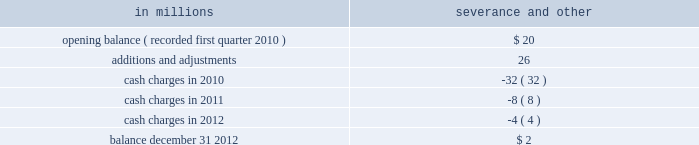The table presents a rollforward of the severance and other costs for approximately 1650 employees included in the 2010 restructuring charg- in millions severance and other .
As of december 31 , 2012 , 1638 employees had left the company under these programs .
Cellulosic bio-fuel tax credit in a memorandum dated june 28 , 2010 , the irs concluded that black liquor would qualify for the cellulosic bio-fuel tax credit of $ 1.01 per gallon pro- duced in 2009 .
On october 15 , 2010 , the irs ruled that companies may qualify in the same year for the $ 0.50 per gallon alternative fuel mixture credit and the $ 1.01 cellulosic bio-fuel tax credit for 2009 , but not for the same gallons of fuel produced and con- sumed .
To the extent a taxpayer changes its position and uses the $ 1.01 credit , it must re-pay the refunds they received as alternative fuel mixture credits attributable to the gallons converted to the cellulosic bio-fuel credit .
The repayment of this refund must include interest .
One important difference between the two credits is that the $ 1.01 credit must be credited against a company 2019s federal tax liability , and the credit may be carried forward through 2015 .
In contrast , the $ 0.50 credit is refundable in cash .
Also , the cellulosic bio- fuel credit is required to be included in federal tax- able income .
The company filed an application with the irs on november 18 , 2010 , to receive the required registra- tion code to become a registered cellulosic bio-fuel producer .
The company received its registration code on february 28 , 2011 .
The company has evaluated the optimal use of the two credits with respect to gallons produced in 2009 .
Considerations include uncertainty around future federal taxable income , the taxability of the alter- native fuel mixture credit , future liquidity and uses of cash such as , but not limited to , acquisitions , debt repayments and voluntary pension contributions versus repayment of alternative fuel mixture credits with interest .
At the present time , the company does not intend to convert any gallons under the alter- native fuel mixture credit to gallons under the cellulosic bio-fuel credit .
On july 19 , 2011 the com- pany filed an amended 2009 tax return claiming alternative fuel mixture tax credits as non-taxable income .
If that amended position is not upheld , the company will re-evaluate its position with regard to alternative fuel mixture gallons produced in 2009 .
During 2009 , the company produced 64 million gal- lons of black liquor that were not eligible for the alternative fuel mixture credit .
The company claimed these gallons for the cellulosic bio-fuel credit by amending the company 2019s 2009 tax return .
The impact of this amendment was included in the company 2019s 2010 fourth quarter income tax provision ( benefit ) , resulting in a $ 40 million net credit to tax expense .
Temple-inland , inc .
Also recognized an income tax benefit of $ 83 million in 2010 related to cellulosic bio-fuel credits .
As is the case with other tax credits , taxpayer claims are subject to possible future review by the irs which has the authority to propose adjustments to the amounts claimed , or credits received .
Note 5 acquisitions and joint ventures acquisitions 2013 : on january 3 , 2013 , international paper completed the acquisition ( effective date of acquis- ition on january 1 , 2013 ) of the shares of its joint venture partner , sabanci holding , in the turkish corrugated packaging company , olmuksa interna- tional paper sabanci ambalaj sanayi ve ticaret a.s .
( olmuksa ) , for a purchase price of $ 56 million .
The acquired shares represent 43.7% ( 43.7 % ) of olmuksa 2019s shares , and prior to this acquisition , international paper already held a 43.7% ( 43.7 % ) equity interest in olmuk- sa .
Thus , international paper now owns 87.4% ( 87.4 % ) of olmuksa 2019s outstanding and issued shares .
The company has not completed the valuation of assets acquired and liabilities assumed ; however , the company anticipates providing a preliminary pur- chase price allocation in its 2013 first quarter form 10-q filing .
Because the transaction resulted in international paper becoming the majority shareholder , owning 87.4% ( 87.4 % ) of olmuksa 2019s shares , its completion triggered a mandatory call for tender of the remaining public shares .
Also as a result of international paper taking majority control of the entity , olmuksa 2019s financial results will be consolidated with our industrial pack- aging segment beginning with the effective date international paper obtained majority control of the entity on january 1 , 2013 .
Pro forma information related to the acquisition of olmuksa has not been included as it does not have a material effect on the company 2019s consolidated results of operations .
2012 : on february 13 , 2012 , international paper com- pleted the acquisition of temple-inland , inc .
( temple- inland ) .
International paper acquired all of the outstanding common stock of temple-inland for $ 32.00 per share in cash , totaling approximately $ 3.7 billion .
What was the total approximate number of shares international paper acquired of the outstanding common stock of temple-inland? 
Computations: (3.7 / 32)
Answer: 0.11563. 